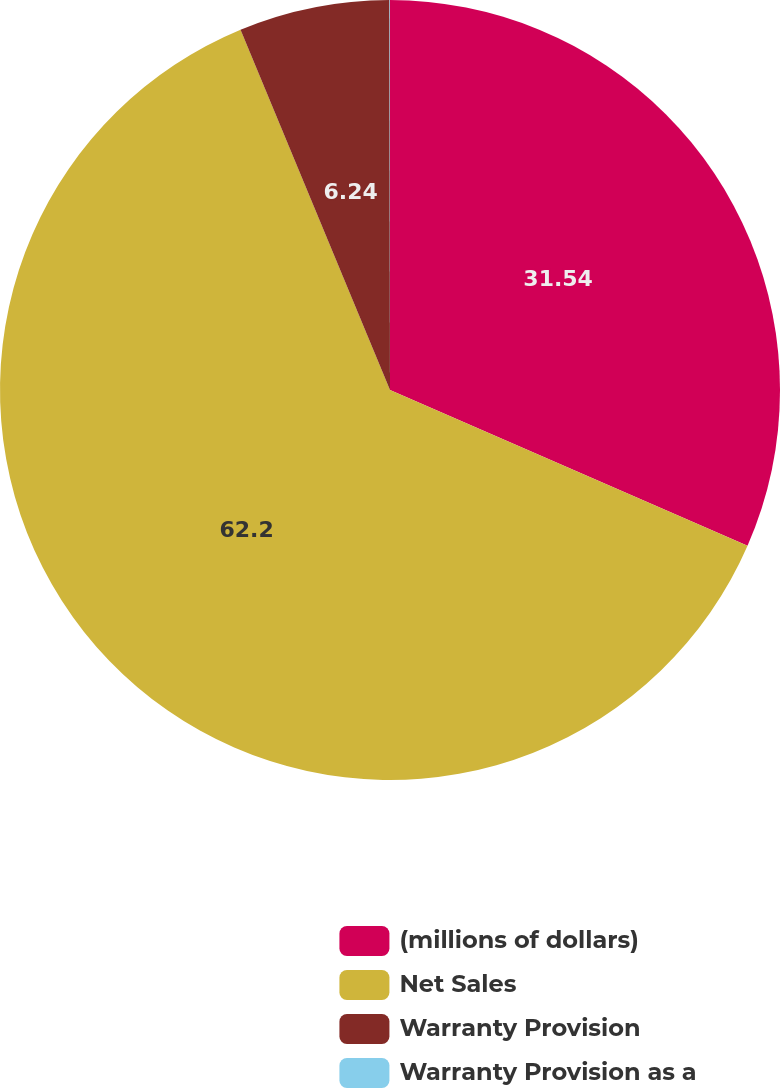Convert chart to OTSL. <chart><loc_0><loc_0><loc_500><loc_500><pie_chart><fcel>(millions of dollars)<fcel>Net Sales<fcel>Warranty Provision<fcel>Warranty Provision as a<nl><fcel>31.54%<fcel>62.2%<fcel>6.24%<fcel>0.02%<nl></chart> 